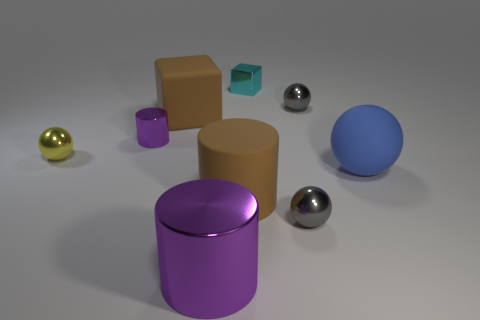Is the small cylinder the same color as the big shiny cylinder?
Offer a very short reply. Yes. Do the small yellow thing and the large brown matte thing that is behind the yellow shiny ball have the same shape?
Your response must be concise. No. There is a metallic cylinder behind the gray thing in front of the gray thing that is behind the brown cylinder; what is its color?
Give a very brief answer. Purple. How many things are brown matte things to the left of the rubber cylinder or large rubber things to the left of the large purple object?
Make the answer very short. 1. How many other things are the same color as the large metallic thing?
Provide a short and direct response. 1. There is a big brown object that is behind the small yellow metallic ball; does it have the same shape as the small cyan shiny thing?
Keep it short and to the point. Yes. Are there fewer gray shiny objects that are on the left side of the small metal block than small gray spheres?
Offer a terse response. Yes. Is there a cyan cube made of the same material as the tiny purple object?
Keep it short and to the point. Yes. There is a ball that is the same size as the brown matte cylinder; what material is it?
Keep it short and to the point. Rubber. Are there fewer large matte balls left of the large sphere than balls that are right of the brown matte cylinder?
Offer a terse response. Yes. 